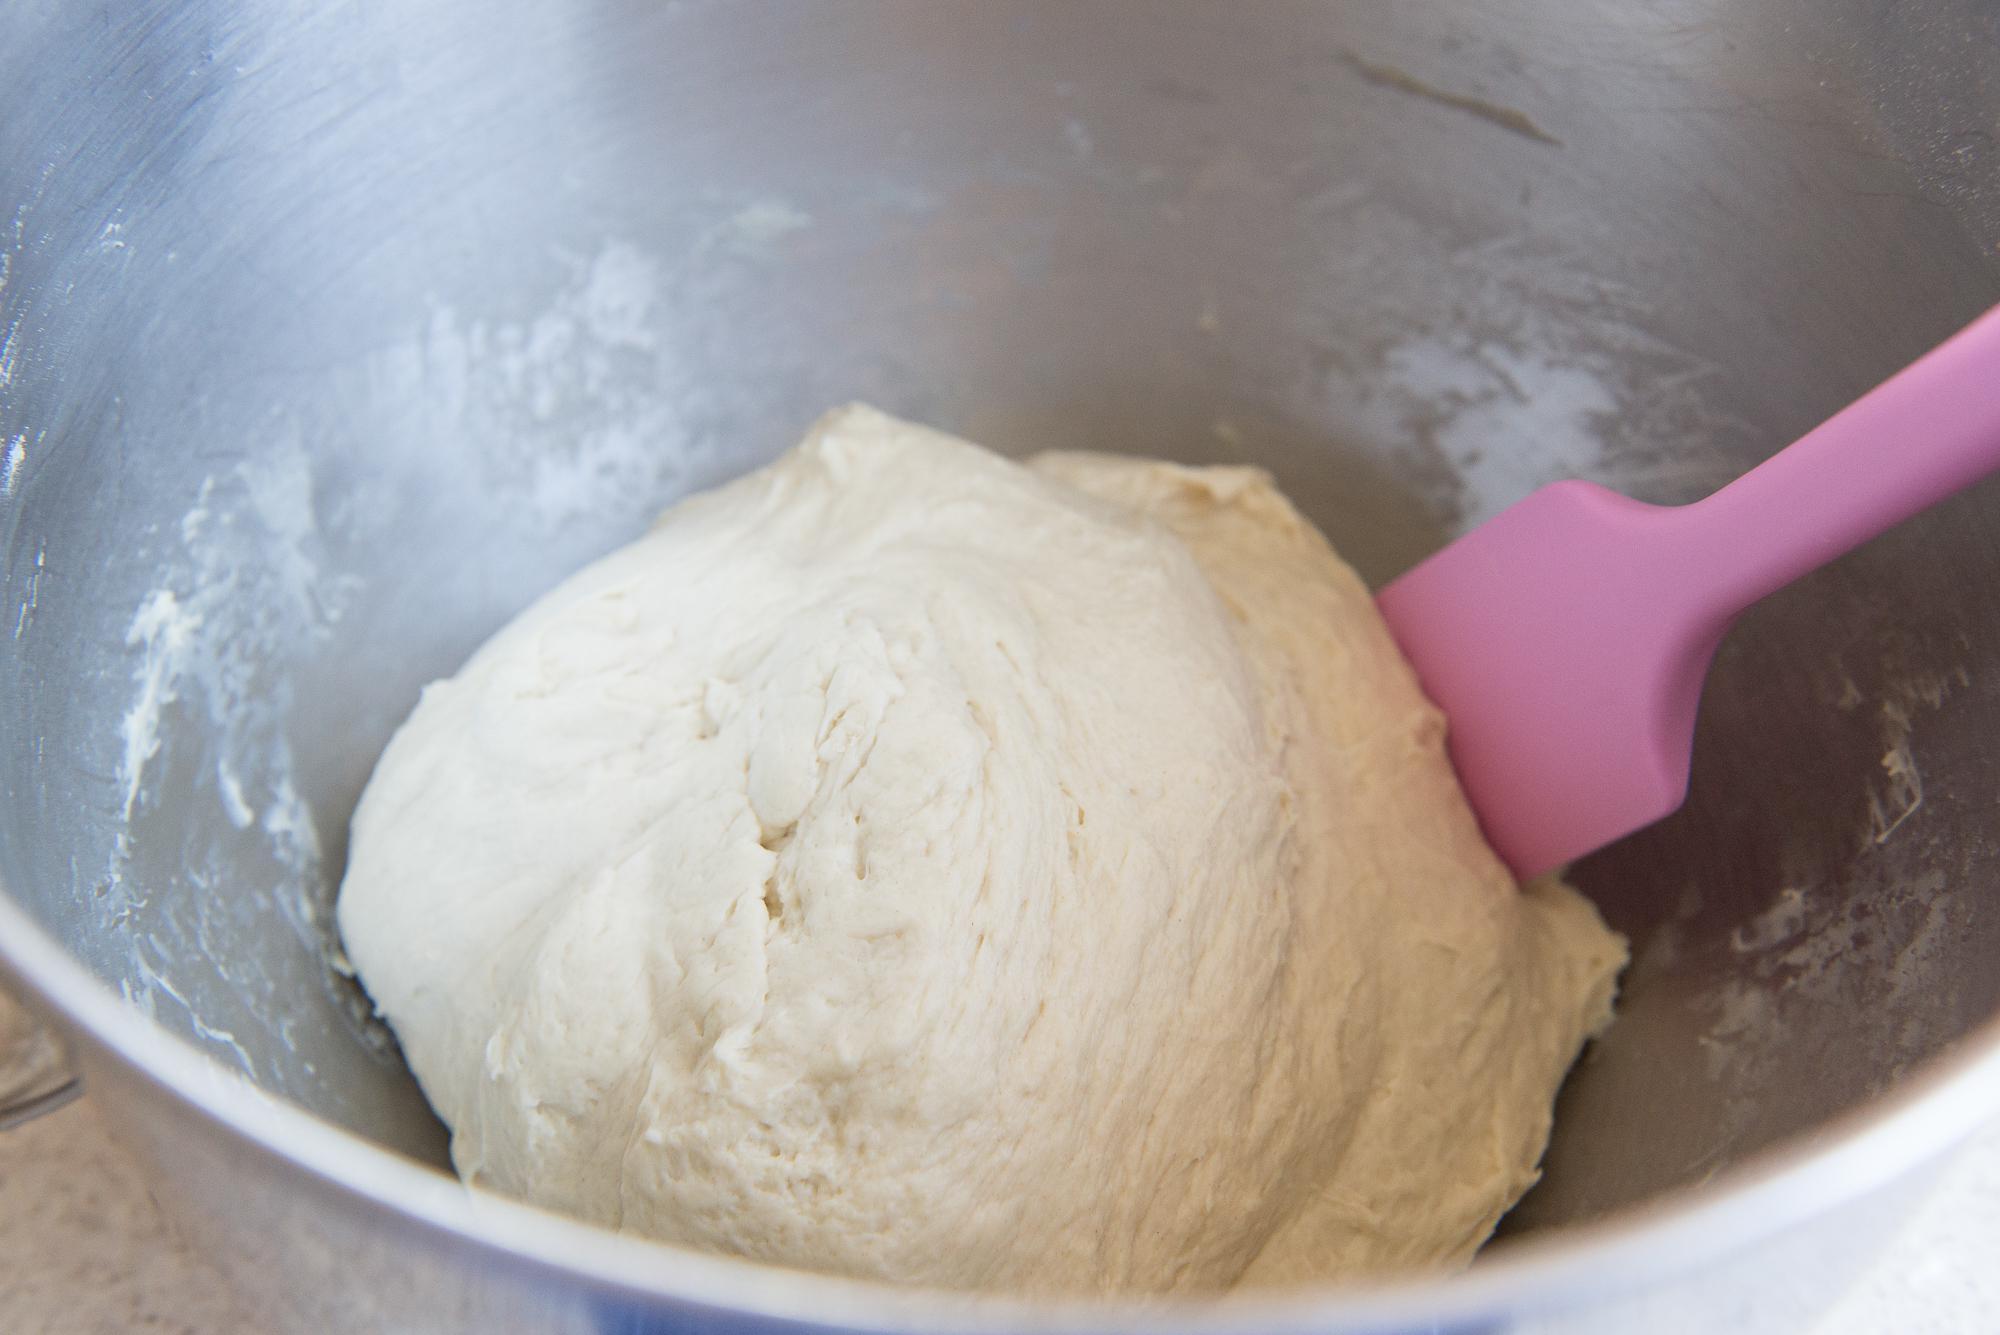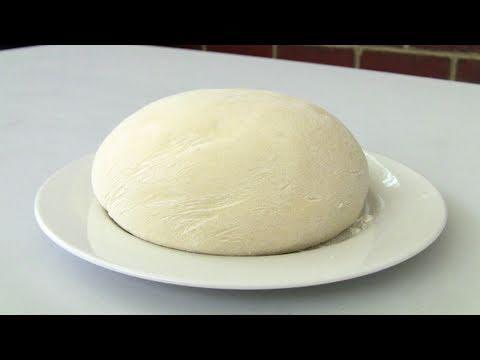The first image is the image on the left, the second image is the image on the right. Analyze the images presented: Is the assertion "In one image the dough has been rolled." valid? Answer yes or no. No. The first image is the image on the left, the second image is the image on the right. Considering the images on both sides, is "One image shows a round ball of dough on a white plate that rests on a white cloth, and the other image shows a flattened round dough shape." valid? Answer yes or no. No. 